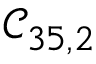<formula> <loc_0><loc_0><loc_500><loc_500>\mathcal { C } _ { 3 5 , 2 }</formula> 